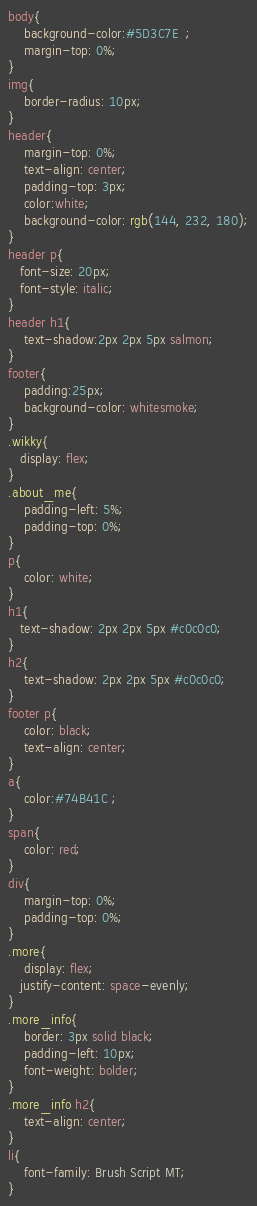Convert code to text. <code><loc_0><loc_0><loc_500><loc_500><_CSS_>body{
    background-color:#5D3C7E  ;
    margin-top: 0%;
}
img{
    border-radius: 10px;
}
header{
    margin-top: 0%;
    text-align: center;
    padding-top: 3px;
    color:white;
    background-color: rgb(144, 232, 180);
}
header p{
   font-size: 20px;
   font-style: italic;
}
header h1{
    text-shadow:2px 2px 5px salmon;
}
footer{
    padding:25px;
    background-color: whitesmoke;
}
.wikky{
   display: flex;
}
.about_me{
    padding-left: 5%;
    padding-top: 0%;
}
p{
    color: white;
}
h1{
   text-shadow: 2px 2px 5px #c0c0c0;
}
h2{
    text-shadow: 2px 2px 5px #c0c0c0;
}
footer p{
    color: black;
    text-align: center;
}
a{
    color:#74B41C ;
}
span{
    color: red;
}
div{
    margin-top: 0%;
    padding-top: 0%;
}
.more{
    display: flex;
   justify-content: space-evenly;
}
.more_info{
    border: 3px solid black;
    padding-left: 10px;
    font-weight: bolder;
}
.more_info h2{
    text-align: center;
}
li{
    font-family: Brush Script MT;
}
</code> 